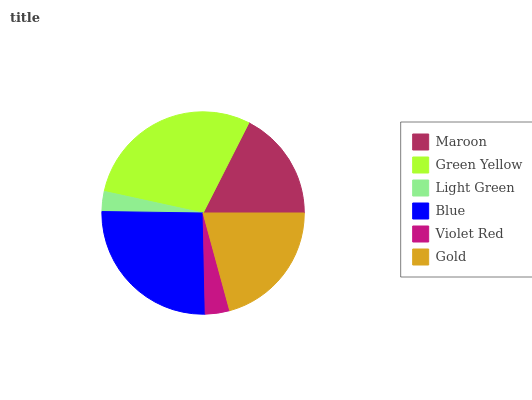Is Light Green the minimum?
Answer yes or no. Yes. Is Green Yellow the maximum?
Answer yes or no. Yes. Is Green Yellow the minimum?
Answer yes or no. No. Is Light Green the maximum?
Answer yes or no. No. Is Green Yellow greater than Light Green?
Answer yes or no. Yes. Is Light Green less than Green Yellow?
Answer yes or no. Yes. Is Light Green greater than Green Yellow?
Answer yes or no. No. Is Green Yellow less than Light Green?
Answer yes or no. No. Is Gold the high median?
Answer yes or no. Yes. Is Maroon the low median?
Answer yes or no. Yes. Is Maroon the high median?
Answer yes or no. No. Is Green Yellow the low median?
Answer yes or no. No. 